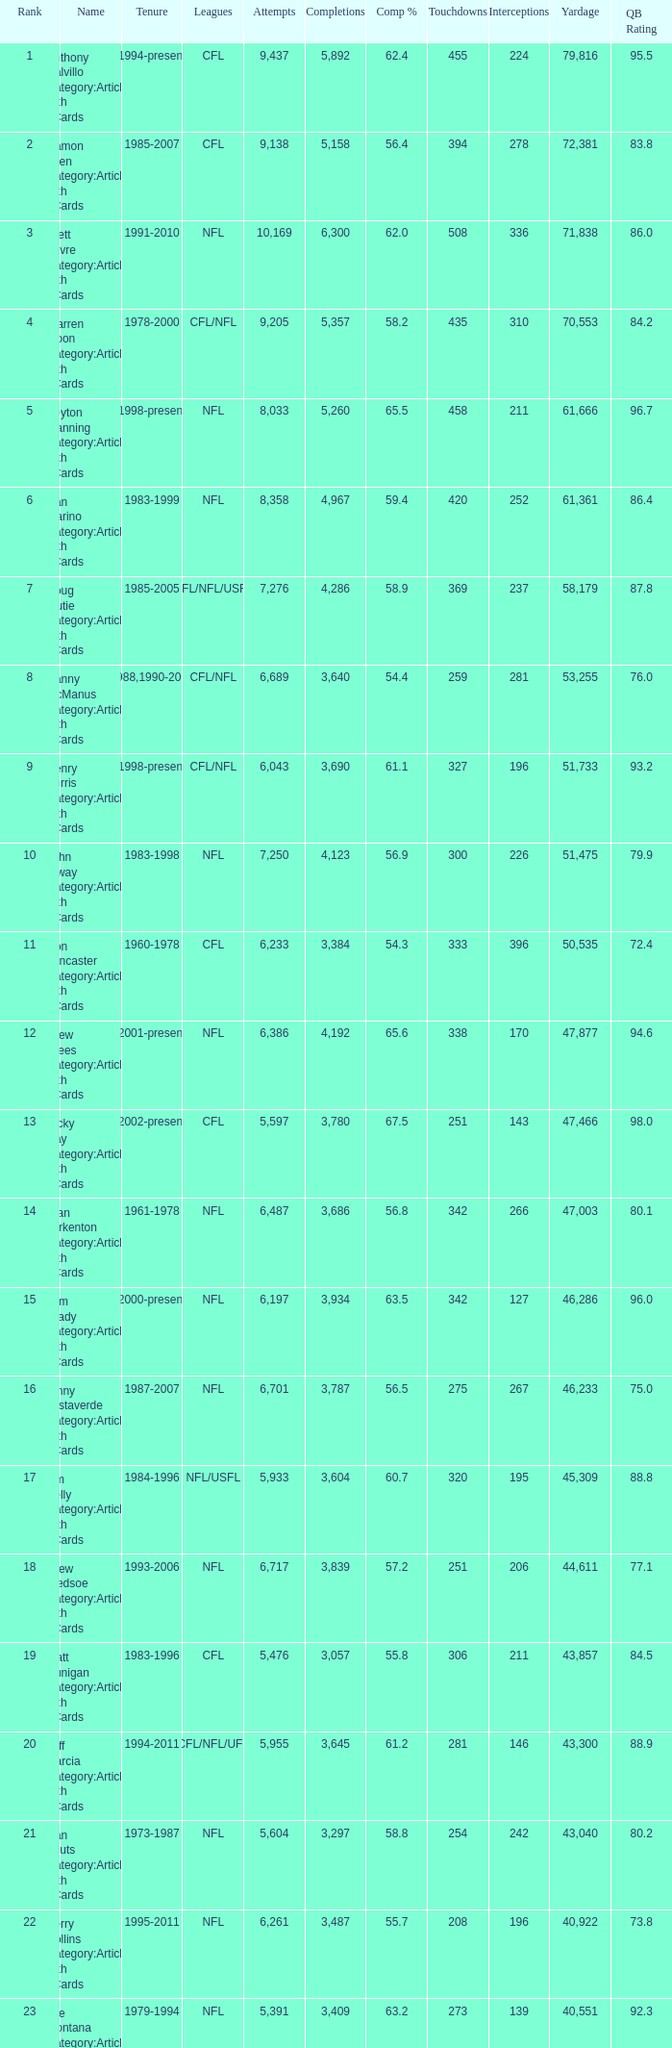If there are more than 4,123 completions and the completion percentage is above 65.6%, what is the corresponding rank? None. Help me parse the entirety of this table. {'header': ['Rank', 'Name', 'Tenure', 'Leagues', 'Attempts', 'Completions', 'Comp %', 'Touchdowns', 'Interceptions', 'Yardage', 'QB Rating'], 'rows': [['1', 'Anthony Calvillo Category:Articles with hCards', '1994-present', 'CFL', '9,437', '5,892', '62.4', '455', '224', '79,816', '95.5'], ['2', 'Damon Allen Category:Articles with hCards', '1985-2007', 'CFL', '9,138', '5,158', '56.4', '394', '278', '72,381', '83.8'], ['3', 'Brett Favre Category:Articles with hCards', '1991-2010', 'NFL', '10,169', '6,300', '62.0', '508', '336', '71,838', '86.0'], ['4', 'Warren Moon Category:Articles with hCards', '1978-2000', 'CFL/NFL', '9,205', '5,357', '58.2', '435', '310', '70,553', '84.2'], ['5', 'Peyton Manning Category:Articles with hCards', '1998-present', 'NFL', '8,033', '5,260', '65.5', '458', '211', '61,666', '96.7'], ['6', 'Dan Marino Category:Articles with hCards', '1983-1999', 'NFL', '8,358', '4,967', '59.4', '420', '252', '61,361', '86.4'], ['7', 'Doug Flutie Category:Articles with hCards', '1985-2005', 'CFL/NFL/USFL', '7,276', '4,286', '58.9', '369', '237', '58,179', '87.8'], ['8', 'Danny McManus Category:Articles with hCards', '1988,1990-2006', 'CFL/NFL', '6,689', '3,640', '54.4', '259', '281', '53,255', '76.0'], ['9', 'Henry Burris Category:Articles with hCards', '1998-present', 'CFL/NFL', '6,043', '3,690', '61.1', '327', '196', '51,733', '93.2'], ['10', 'John Elway Category:Articles with hCards', '1983-1998', 'NFL', '7,250', '4,123', '56.9', '300', '226', '51,475', '79.9'], ['11', 'Ron Lancaster Category:Articles with hCards', '1960-1978', 'CFL', '6,233', '3,384', '54.3', '333', '396', '50,535', '72.4'], ['12', 'Drew Brees Category:Articles with hCards', '2001-present', 'NFL', '6,386', '4,192', '65.6', '338', '170', '47,877', '94.6'], ['13', 'Ricky Ray Category:Articles with hCards', '2002-present', 'CFL', '5,597', '3,780', '67.5', '251', '143', '47,466', '98.0'], ['14', 'Fran Tarkenton Category:Articles with hCards', '1961-1978', 'NFL', '6,487', '3,686', '56.8', '342', '266', '47,003', '80.1'], ['15', 'Tom Brady Category:Articles with hCards', '2000-present', 'NFL', '6,197', '3,934', '63.5', '342', '127', '46,286', '96.0'], ['16', 'Vinny Testaverde Category:Articles with hCards', '1987-2007', 'NFL', '6,701', '3,787', '56.5', '275', '267', '46,233', '75.0'], ['17', 'Jim Kelly Category:Articles with hCards', '1984-1996', 'NFL/USFL', '5,933', '3,604', '60.7', '320', '195', '45,309', '88.8'], ['18', 'Drew Bledsoe Category:Articles with hCards', '1993-2006', 'NFL', '6,717', '3,839', '57.2', '251', '206', '44,611', '77.1'], ['19', 'Matt Dunigan Category:Articles with hCards', '1983-1996', 'CFL', '5,476', '3,057', '55.8', '306', '211', '43,857', '84.5'], ['20', 'Jeff Garcia Category:Articles with hCards', '1994-2011', 'CFL/NFL/UFL', '5,955', '3,645', '61.2', '281', '146', '43,300', '88.9'], ['21', 'Dan Fouts Category:Articles with hCards', '1973-1987', 'NFL', '5,604', '3,297', '58.8', '254', '242', '43,040', '80.2'], ['22', 'Kerry Collins Category:Articles with hCards', '1995-2011', 'NFL', '6,261', '3,487', '55.7', '208', '196', '40,922', '73.8'], ['23', 'Joe Montana Category:Articles with hCards', '1979-1994', 'NFL', '5,391', '3,409', '63.2', '273', '139', '40,551', '92.3'], ['24', 'Tracy Ham Category:Articles with hCards', '1987-1999', 'CFL', '4,945', '2,670', '54.0', '284', '164', '40,534', '86.6'], ['25', 'Johnny Unitas Category:Articles with hCards', '1956-1973', 'NFL', '5,186', '2,830', '54.6', '290', '253', '40,239', '78.2']]} 